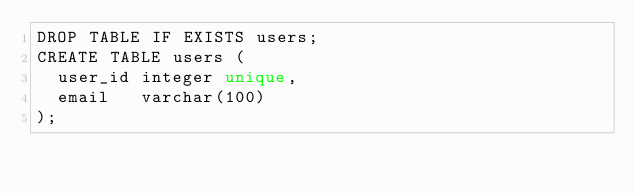Convert code to text. <code><loc_0><loc_0><loc_500><loc_500><_SQL_>DROP TABLE IF EXISTS users;
CREATE TABLE users (
  user_id integer unique,
  email   varchar(100)
);</code> 